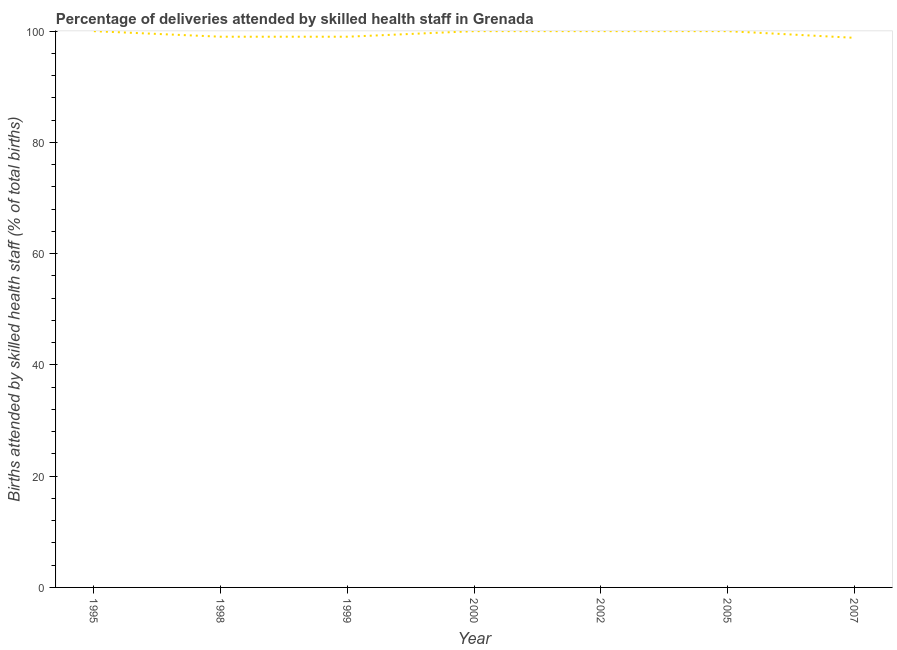What is the number of births attended by skilled health staff in 2007?
Provide a succinct answer. 98.8. Across all years, what is the minimum number of births attended by skilled health staff?
Offer a terse response. 98.8. What is the sum of the number of births attended by skilled health staff?
Provide a short and direct response. 696.8. What is the average number of births attended by skilled health staff per year?
Keep it short and to the point. 99.54. What is the median number of births attended by skilled health staff?
Your answer should be compact. 100. Do a majority of the years between 2002 and 2005 (inclusive) have number of births attended by skilled health staff greater than 76 %?
Your answer should be very brief. Yes. What is the ratio of the number of births attended by skilled health staff in 2000 to that in 2007?
Offer a very short reply. 1.01. Is the number of births attended by skilled health staff in 1999 less than that in 2002?
Offer a very short reply. Yes. What is the difference between the highest and the second highest number of births attended by skilled health staff?
Your answer should be compact. 0. Is the sum of the number of births attended by skilled health staff in 1995 and 2000 greater than the maximum number of births attended by skilled health staff across all years?
Your response must be concise. Yes. What is the difference between the highest and the lowest number of births attended by skilled health staff?
Offer a very short reply. 1.2. In how many years, is the number of births attended by skilled health staff greater than the average number of births attended by skilled health staff taken over all years?
Provide a succinct answer. 4. Does the number of births attended by skilled health staff monotonically increase over the years?
Your answer should be very brief. No. How many lines are there?
Offer a terse response. 1. What is the difference between two consecutive major ticks on the Y-axis?
Provide a short and direct response. 20. Are the values on the major ticks of Y-axis written in scientific E-notation?
Give a very brief answer. No. Does the graph contain any zero values?
Offer a terse response. No. What is the title of the graph?
Provide a short and direct response. Percentage of deliveries attended by skilled health staff in Grenada. What is the label or title of the Y-axis?
Make the answer very short. Births attended by skilled health staff (% of total births). What is the Births attended by skilled health staff (% of total births) in 1999?
Keep it short and to the point. 99. What is the Births attended by skilled health staff (% of total births) in 2002?
Give a very brief answer. 100. What is the Births attended by skilled health staff (% of total births) of 2005?
Provide a short and direct response. 100. What is the Births attended by skilled health staff (% of total births) of 2007?
Your response must be concise. 98.8. What is the difference between the Births attended by skilled health staff (% of total births) in 1995 and 2000?
Keep it short and to the point. 0. What is the difference between the Births attended by skilled health staff (% of total births) in 1995 and 2002?
Offer a very short reply. 0. What is the difference between the Births attended by skilled health staff (% of total births) in 1995 and 2005?
Ensure brevity in your answer.  0. What is the difference between the Births attended by skilled health staff (% of total births) in 1998 and 1999?
Provide a short and direct response. 0. What is the difference between the Births attended by skilled health staff (% of total births) in 1998 and 2007?
Offer a very short reply. 0.2. What is the difference between the Births attended by skilled health staff (% of total births) in 1999 and 2000?
Provide a short and direct response. -1. What is the difference between the Births attended by skilled health staff (% of total births) in 1999 and 2002?
Make the answer very short. -1. What is the difference between the Births attended by skilled health staff (% of total births) in 1999 and 2007?
Your response must be concise. 0.2. What is the difference between the Births attended by skilled health staff (% of total births) in 2000 and 2002?
Provide a short and direct response. 0. What is the difference between the Births attended by skilled health staff (% of total births) in 2005 and 2007?
Provide a succinct answer. 1.2. What is the ratio of the Births attended by skilled health staff (% of total births) in 1995 to that in 2007?
Your answer should be compact. 1.01. What is the ratio of the Births attended by skilled health staff (% of total births) in 1998 to that in 1999?
Keep it short and to the point. 1. What is the ratio of the Births attended by skilled health staff (% of total births) in 1998 to that in 2002?
Keep it short and to the point. 0.99. What is the ratio of the Births attended by skilled health staff (% of total births) in 1998 to that in 2005?
Keep it short and to the point. 0.99. What is the ratio of the Births attended by skilled health staff (% of total births) in 1999 to that in 2005?
Give a very brief answer. 0.99. What is the ratio of the Births attended by skilled health staff (% of total births) in 1999 to that in 2007?
Ensure brevity in your answer.  1. What is the ratio of the Births attended by skilled health staff (% of total births) in 2000 to that in 2007?
Provide a short and direct response. 1.01. What is the ratio of the Births attended by skilled health staff (% of total births) in 2002 to that in 2005?
Your answer should be compact. 1. 